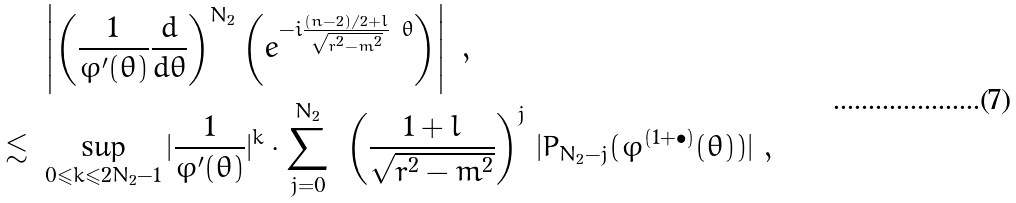<formula> <loc_0><loc_0><loc_500><loc_500>& \left | \left ( \frac { 1 } { \varphi ^ { \prime } ( \theta ) } \frac { d } { d \theta } \right ) ^ { N _ { 2 } } \left ( e ^ { - i \frac { ( n - 2 ) / 2 + l } { \sqrt { r ^ { 2 } - m ^ { 2 } } } \ \theta } \right ) \right | \ , \\ \lesssim \ & \sup _ { 0 \leqslant k \leqslant 2 N _ { 2 } - 1 } | \frac { 1 } { \varphi ^ { \prime } ( \theta ) } | ^ { k } \cdot \sum _ { j = 0 } ^ { N _ { 2 } } \ \left ( \frac { 1 + l } { \sqrt { r ^ { 2 } - m ^ { 2 } } } \right ) ^ { j } \, | P _ { N _ { 2 } - j } ( \varphi ^ { ( 1 + \bullet ) } ( \theta ) ) | \ ,</formula> 